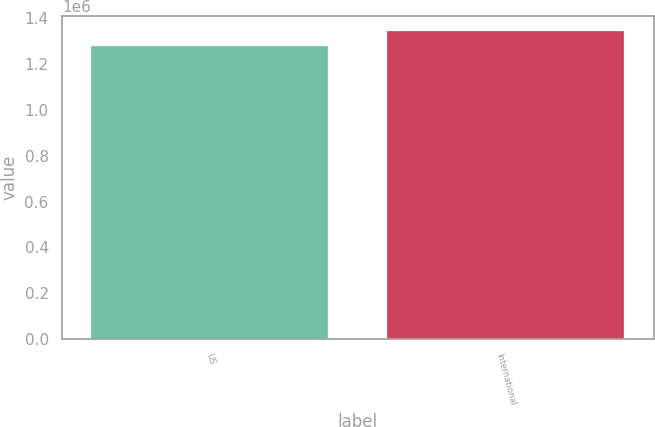<chart> <loc_0><loc_0><loc_500><loc_500><bar_chart><fcel>US<fcel>International<nl><fcel>1.278e+06<fcel>1.341e+06<nl></chart> 